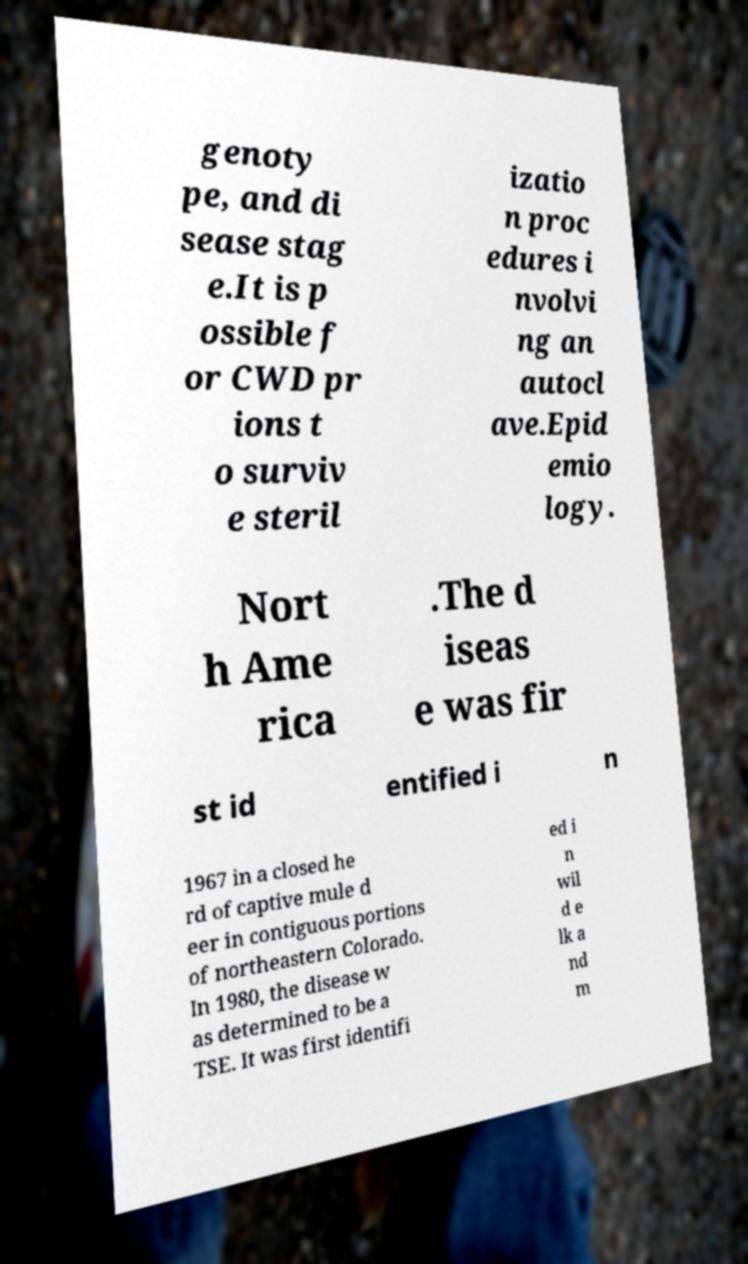Could you assist in decoding the text presented in this image and type it out clearly? genoty pe, and di sease stag e.It is p ossible f or CWD pr ions t o surviv e steril izatio n proc edures i nvolvi ng an autocl ave.Epid emio logy. Nort h Ame rica .The d iseas e was fir st id entified i n 1967 in a closed he rd of captive mule d eer in contiguous portions of northeastern Colorado. In 1980, the disease w as determined to be a TSE. It was first identifi ed i n wil d e lk a nd m 